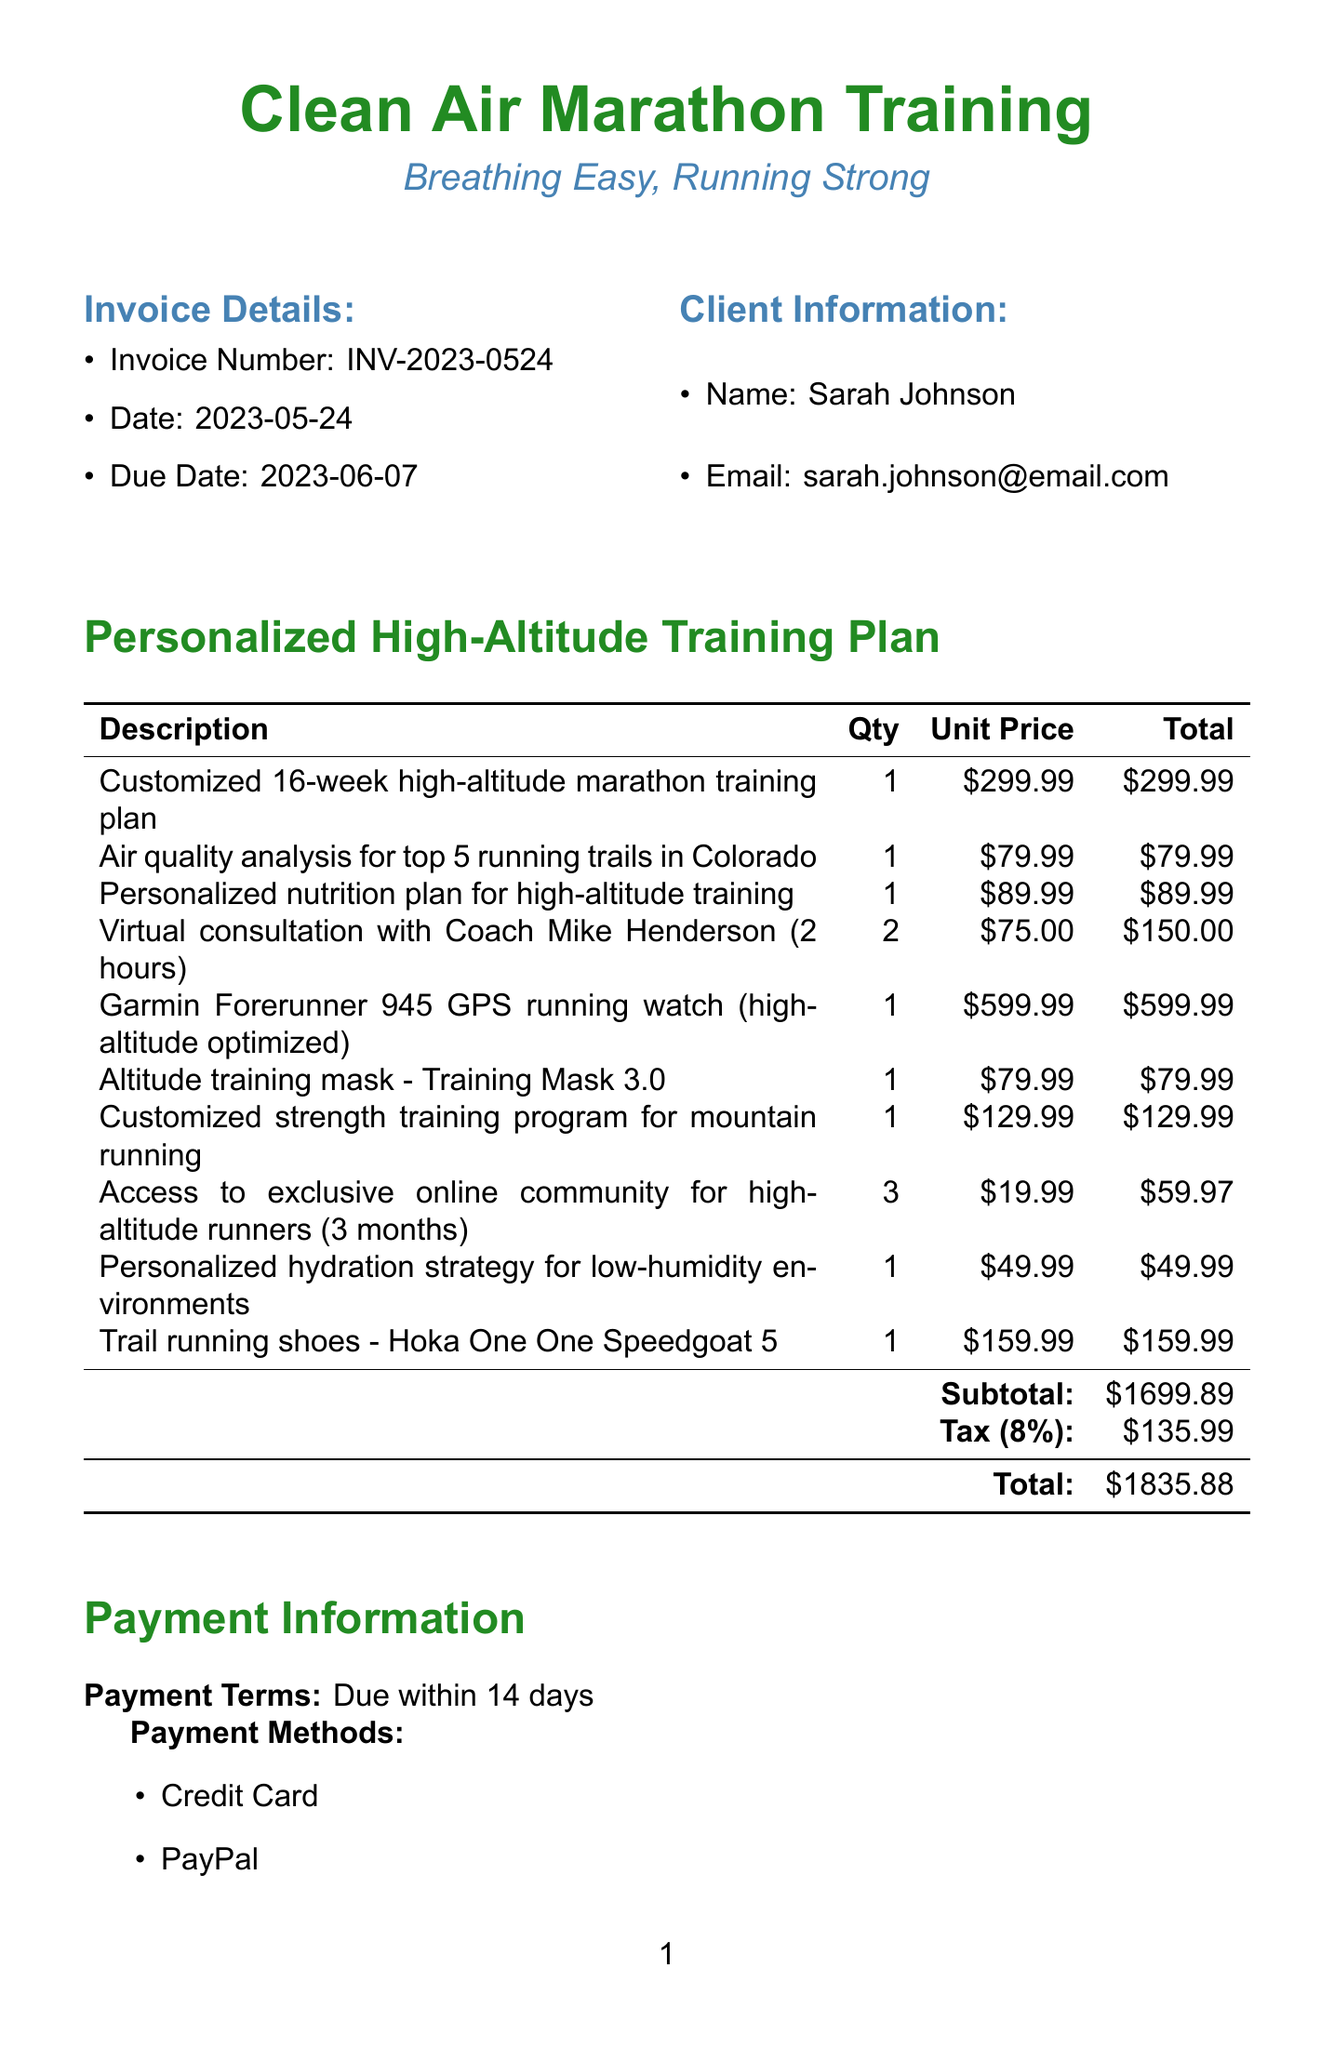What is the invoice number? The invoice number is specified in the document's invoice details section.
Answer: INV-2023-0524 Who is the client? The client's name can be found under the client information section of the document.
Answer: Sarah Johnson What is the total amount due? The total amount is summarized at the bottom of the invoice.
Answer: $1835.88 What is the due date for payment? The due date is listed in the invoice details section.
Answer: 2023-06-07 How many virtual consultation hours are included? The number of hours for virtual consultation is specified in the training plan items section.
Answer: 2 Which item has the highest unit price? The item with the highest unit price can be identified in the training plan items table.
Answer: Garmin Forerunner 945 GPS running watch (high-altitude optimized) What is the payment term? The payment terms are specified in the payment information section of the document.
Answer: Due within 14 days What analysis is included in the training plan? The document includes a specific analysis as part of the training plan items.
Answer: Air quality analysis for top 5 running trails in Colorado How long is the access to the online community? The duration of access to the online community is mentioned in the training plan items.
Answer: 3 months What product is recommended for altitude training? The recommended product for altitude training is mentioned in the training plan items section.
Answer: Altitude training mask - Training Mask 3.0 